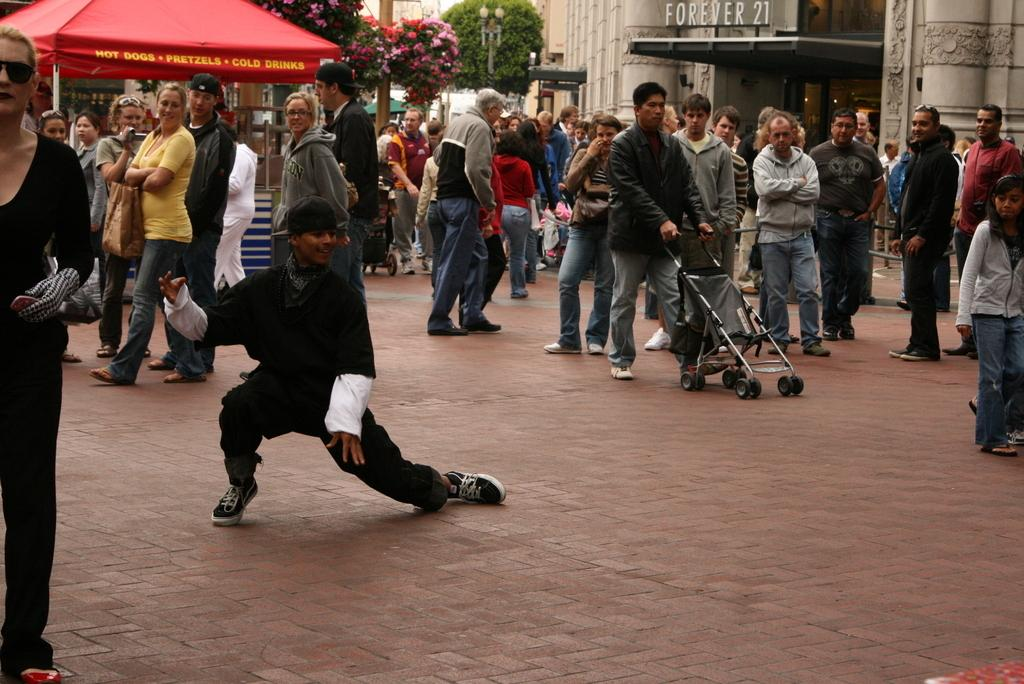What can be seen on the road in the image? There are men and women standing on the road in the image. What is visible in the background of the image? There is a tree, a building, and a shelter in the background of the image. What type of oil can be seen dripping from the tree in the image? There is no oil present in the image, and the tree is not depicted as dripping anything. 